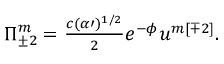Convert formula to latex. <formula><loc_0><loc_0><loc_500><loc_500>\Pi _ { \pm 2 } ^ { m } = { \frac { c ( \alpha \prime ) ^ { 1 / 2 } } { 2 } } e ^ { - \phi } u ^ { m [ \mp 2 ] } .</formula> 